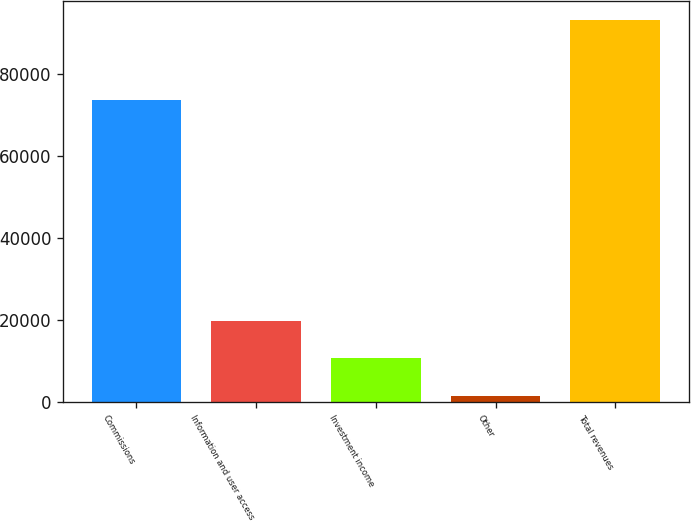Convert chart. <chart><loc_0><loc_0><loc_500><loc_500><bar_chart><fcel>Commissions<fcel>Information and user access<fcel>Investment income<fcel>Other<fcel>Total revenues<nl><fcel>73528<fcel>19816.2<fcel>10657.6<fcel>1499<fcel>93085<nl></chart> 